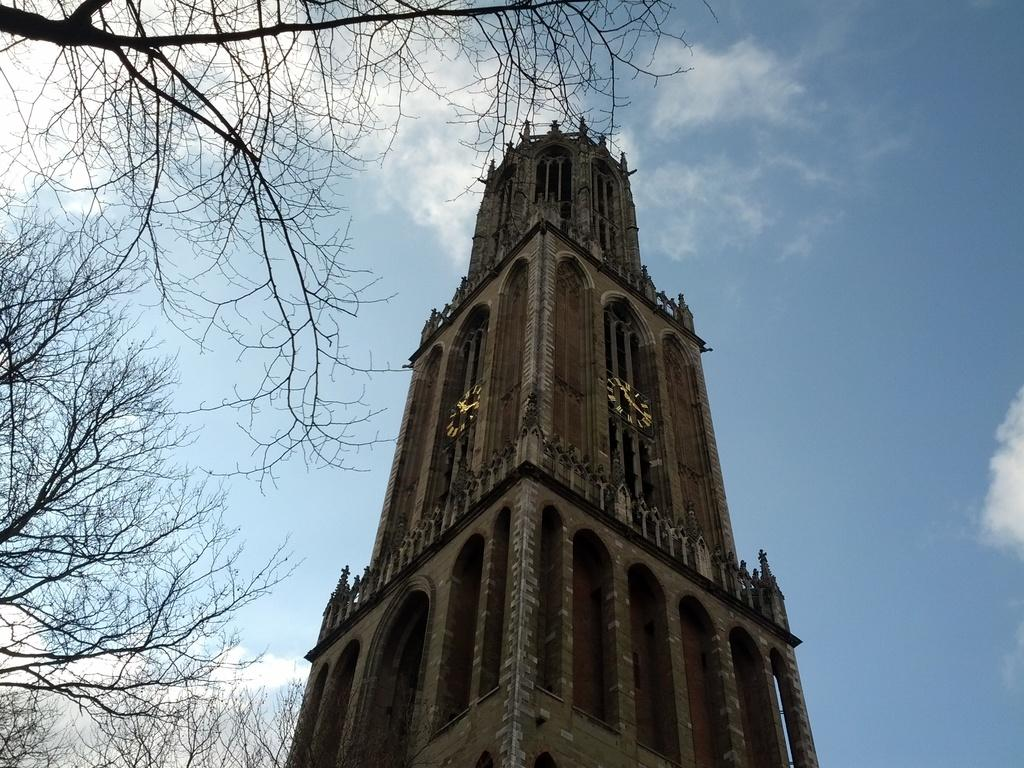What structure is present in the image? There is a building in the image. What type of vegetation is visible beside the building? There are trees beside the building in the image. Can you see a goose making a note while stopping in the image? There is no goose or any indication of note-making or stopping in the image. 